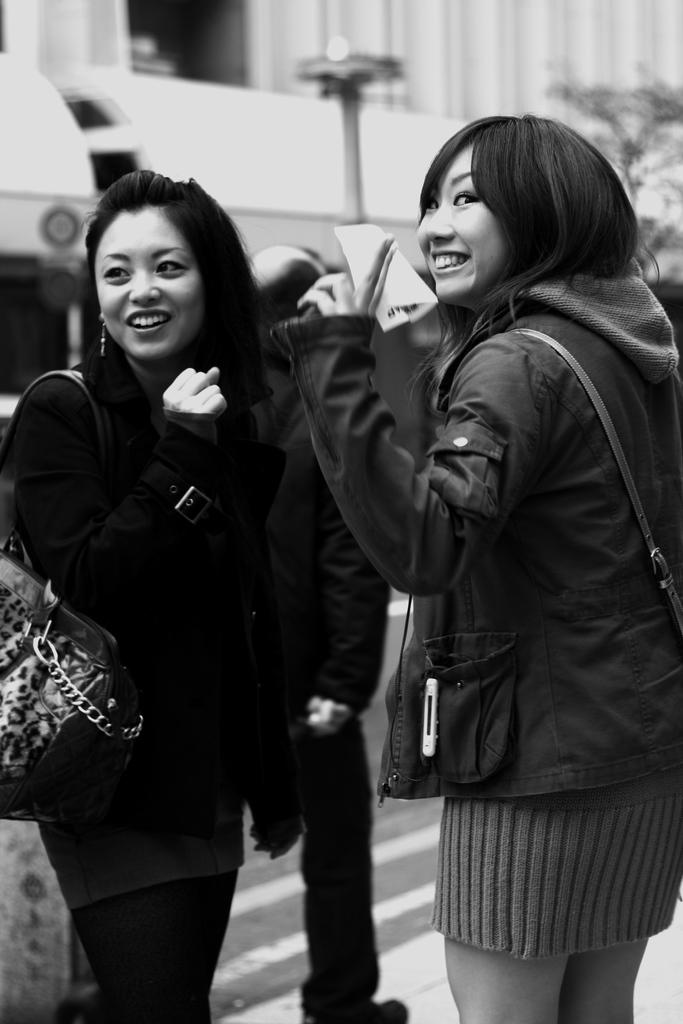What is the color scheme of the image? The image is black and white. How many people are visible in the image? There are two ladies standing in the image, and one person is walking. What can be seen in the background of the image? There is a building in the background of the image. What object is present in the image that is not a person or building? There is a pole in the image. What type of gun can be seen hanging on the curtain in the image? There is no gun or curtain present in the image. Is there a fan visible in the image? There is no fan visible in the image. 